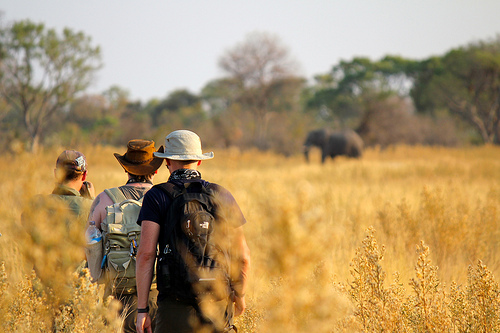Compare the experience of these men on the plain to a similar exploration in a dense jungle. Exploring an open plain is vastly different from exploring a dense jungle. On the plain, visibility is much higher, allowing the men to see wildlife from a distance and prepare accordingly. The terrain is relatively flat, making navigation easier even if the dry grasses pose some difficulty. In contrast, a dense jungle offers limited visibility due to thick vegetation, which can obscure paths and make it challenging to spot wildlife until they are very close. The terrain in a jungle can be varied and difficult, with numerous obstacles like roots, fallen trees, and slippery mud. The climate in a jungle is typically more humid and can be more uncomfortable, while also posing a higher risk of insect bites and encounters with a broader range of potentially dangerous animals. Communication in a jungle may also be more difficult due to the dense foliage blocking radio signals. 